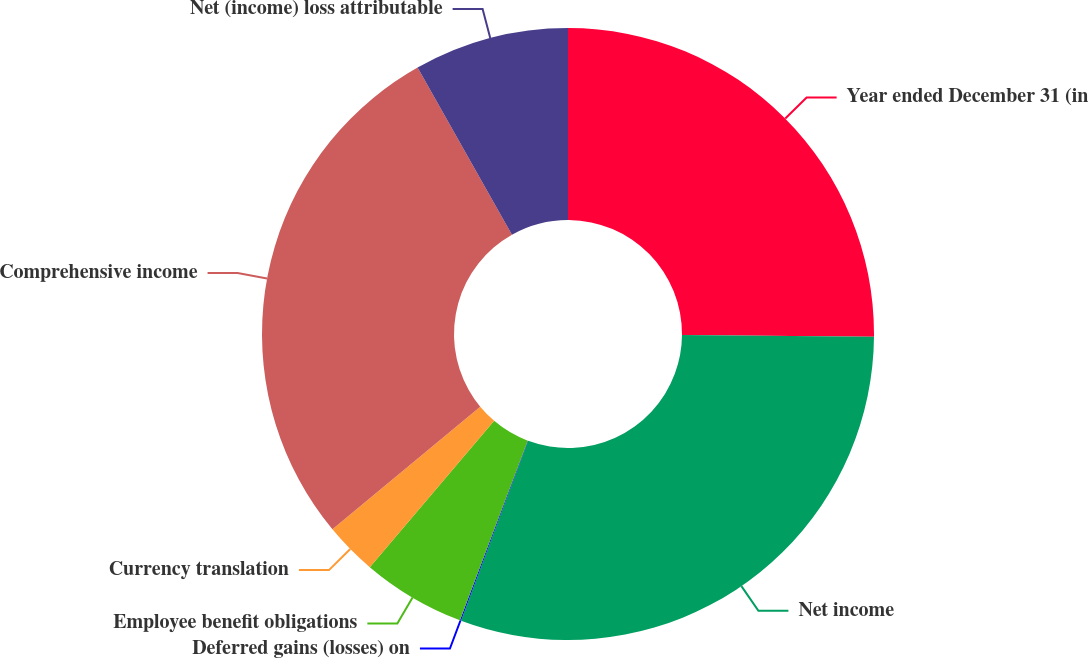<chart> <loc_0><loc_0><loc_500><loc_500><pie_chart><fcel>Year ended December 31 (in<fcel>Net income<fcel>Deferred gains (losses) on<fcel>Employee benefit obligations<fcel>Currency translation<fcel>Comprehensive income<fcel>Net (income) loss attributable<nl><fcel>25.14%<fcel>30.55%<fcel>0.06%<fcel>5.47%<fcel>2.77%<fcel>27.84%<fcel>8.18%<nl></chart> 